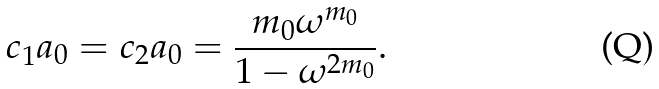<formula> <loc_0><loc_0><loc_500><loc_500>c _ { 1 } a _ { 0 } = c _ { 2 } a _ { 0 } = \frac { m _ { 0 } \omega ^ { m _ { 0 } } } { 1 - \omega ^ { 2 m _ { 0 } } } .</formula> 